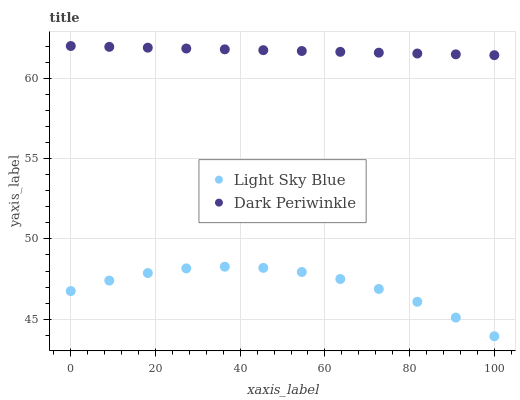Does Light Sky Blue have the minimum area under the curve?
Answer yes or no. Yes. Does Dark Periwinkle have the maximum area under the curve?
Answer yes or no. Yes. Does Dark Periwinkle have the minimum area under the curve?
Answer yes or no. No. Is Dark Periwinkle the smoothest?
Answer yes or no. Yes. Is Light Sky Blue the roughest?
Answer yes or no. Yes. Is Dark Periwinkle the roughest?
Answer yes or no. No. Does Light Sky Blue have the lowest value?
Answer yes or no. Yes. Does Dark Periwinkle have the lowest value?
Answer yes or no. No. Does Dark Periwinkle have the highest value?
Answer yes or no. Yes. Is Light Sky Blue less than Dark Periwinkle?
Answer yes or no. Yes. Is Dark Periwinkle greater than Light Sky Blue?
Answer yes or no. Yes. Does Light Sky Blue intersect Dark Periwinkle?
Answer yes or no. No. 